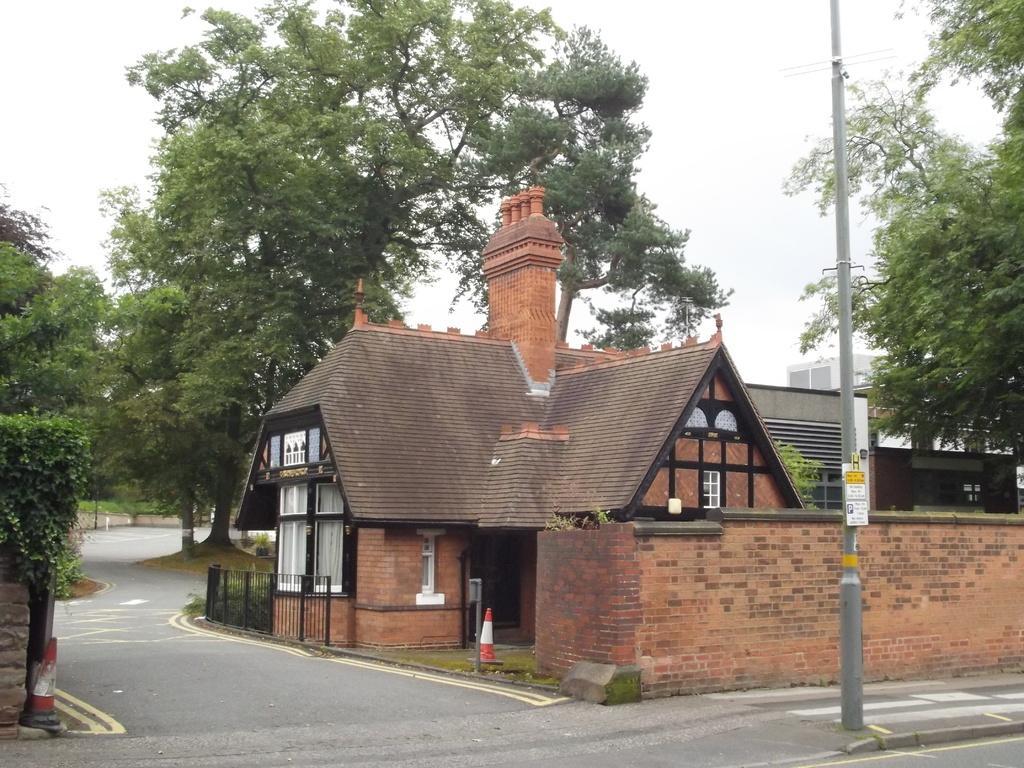Could you give a brief overview of what you see in this image? In this image there is a house in the middle. In front of the house there is a road. In the background there are trees. On the right side there is a pole on the footpath. At the top there is the sky. 